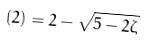<formula> <loc_0><loc_0><loc_500><loc_500>( 2 ) = 2 - \sqrt { 5 - 2 \zeta }</formula> 